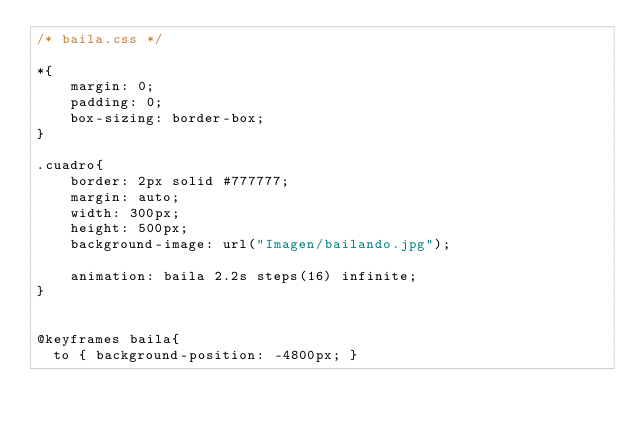Convert code to text. <code><loc_0><loc_0><loc_500><loc_500><_CSS_>/* baila.css */

*{
	margin: 0;
	padding: 0;
	box-sizing: border-box;
}

.cuadro{
	border: 2px solid #777777;
	margin: auto;
	width: 300px;
	height: 500px;
	background-image: url("Imagen/bailando.jpg");
	
	animation: baila 2.2s steps(16) infinite;
}


@keyframes baila{
  to { background-position: -4800px; }
</code> 